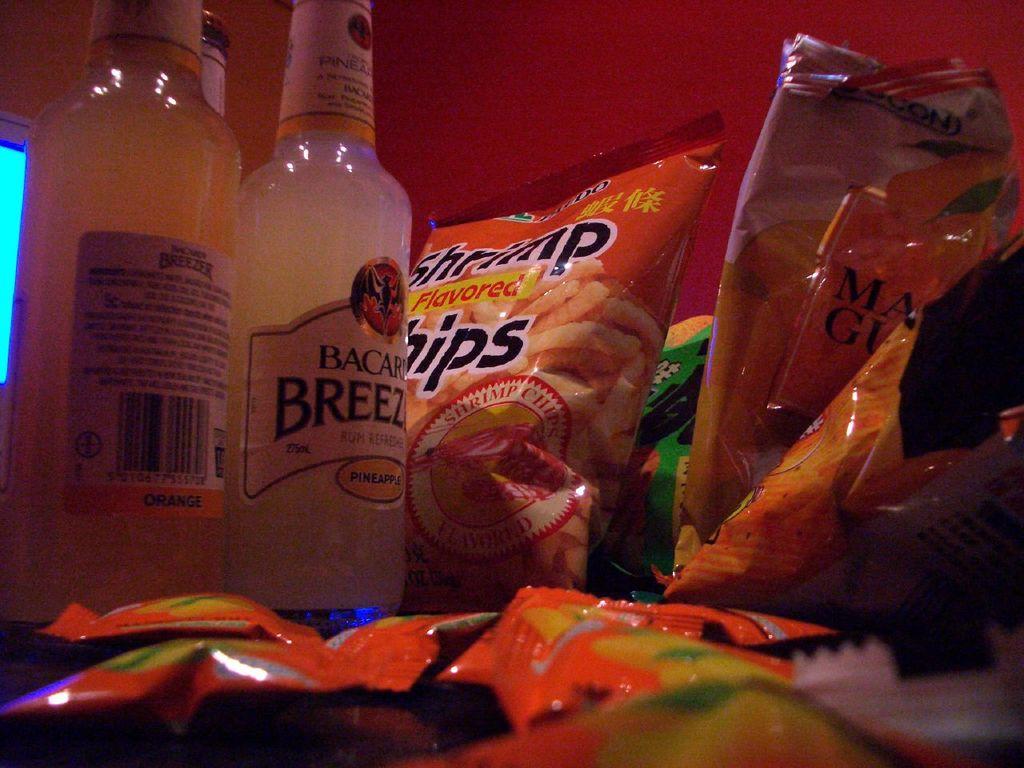What brand of liquor is visible?
Keep it short and to the point. Bacardi. 